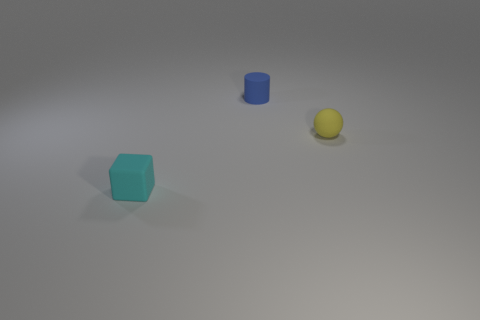Add 3 big brown balls. How many objects exist? 6 Subtract all cylinders. How many objects are left? 2 Subtract all big cyan shiny cylinders. Subtract all matte balls. How many objects are left? 2 Add 2 tiny matte blocks. How many tiny matte blocks are left? 3 Add 3 tiny rubber cylinders. How many tiny rubber cylinders exist? 4 Subtract 0 red spheres. How many objects are left? 3 